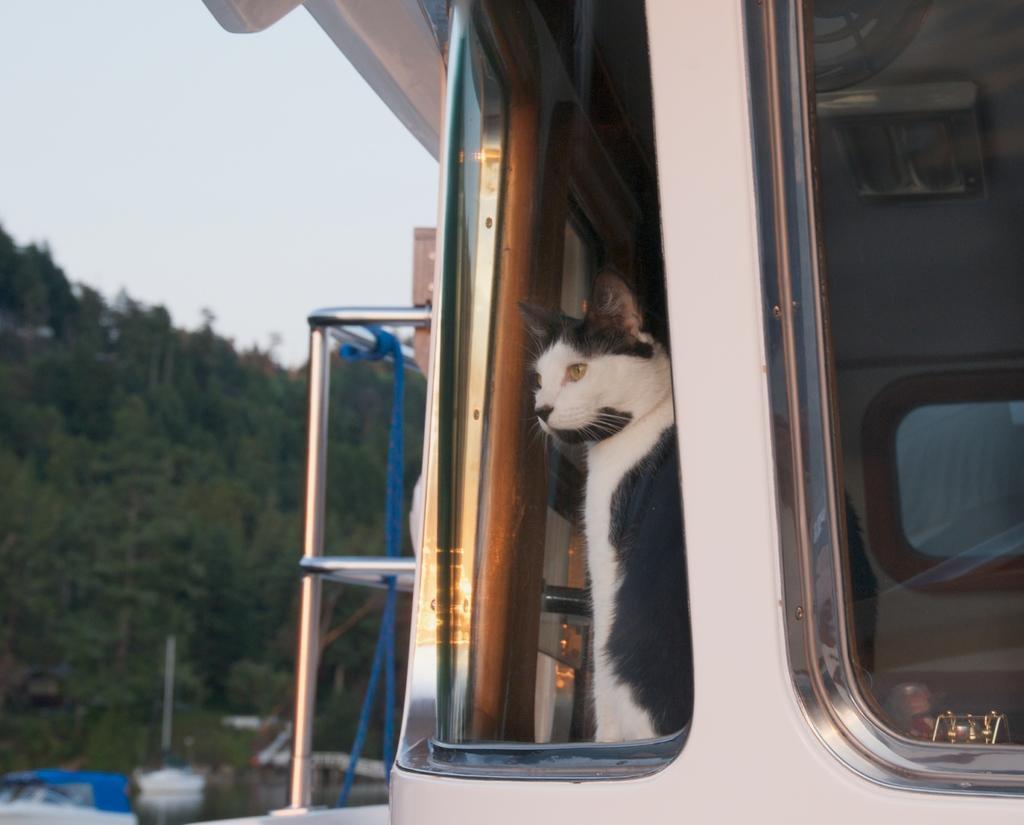Can you describe this image briefly? This picture is clicked outside. On the right we can see a cat and we can see the vehicle and the metal rods. In the background we can see the sky, trees and many other objects. 